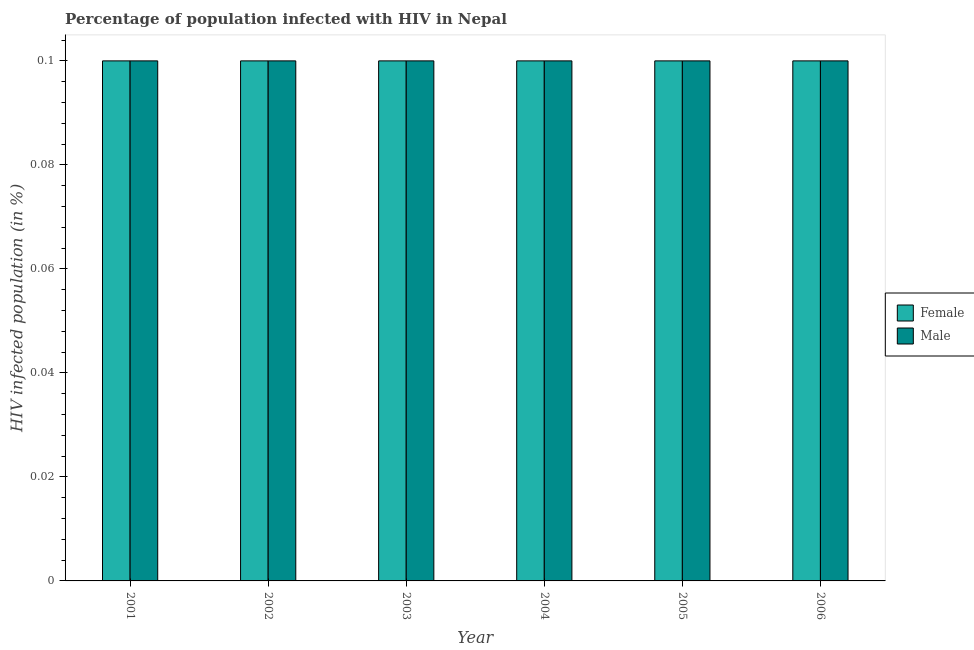How many groups of bars are there?
Your answer should be very brief. 6. Are the number of bars on each tick of the X-axis equal?
Offer a terse response. Yes. How many bars are there on the 2nd tick from the right?
Offer a very short reply. 2. What is the label of the 1st group of bars from the left?
Your response must be concise. 2001. In how many cases, is the number of bars for a given year not equal to the number of legend labels?
Ensure brevity in your answer.  0. Across all years, what is the maximum percentage of females who are infected with hiv?
Your answer should be very brief. 0.1. In which year was the percentage of males who are infected with hiv maximum?
Offer a very short reply. 2001. In which year was the percentage of females who are infected with hiv minimum?
Your answer should be very brief. 2001. What is the average percentage of males who are infected with hiv per year?
Provide a succinct answer. 0.1. In how many years, is the percentage of males who are infected with hiv greater than 0.092 %?
Your answer should be very brief. 6. What is the ratio of the percentage of females who are infected with hiv in 2002 to that in 2005?
Offer a terse response. 1. Is the percentage of males who are infected with hiv in 2002 less than that in 2006?
Your answer should be very brief. No. Is the difference between the percentage of males who are infected with hiv in 2002 and 2005 greater than the difference between the percentage of females who are infected with hiv in 2002 and 2005?
Your answer should be compact. No. What is the difference between the highest and the lowest percentage of females who are infected with hiv?
Your response must be concise. 0. Is the sum of the percentage of males who are infected with hiv in 2002 and 2004 greater than the maximum percentage of females who are infected with hiv across all years?
Your answer should be compact. Yes. What does the 1st bar from the left in 2005 represents?
Keep it short and to the point. Female. How many bars are there?
Keep it short and to the point. 12. Does the graph contain any zero values?
Offer a terse response. No. What is the title of the graph?
Your answer should be very brief. Percentage of population infected with HIV in Nepal. Does "Total Population" appear as one of the legend labels in the graph?
Offer a very short reply. No. What is the label or title of the X-axis?
Offer a terse response. Year. What is the label or title of the Y-axis?
Keep it short and to the point. HIV infected population (in %). What is the HIV infected population (in %) in Male in 2001?
Give a very brief answer. 0.1. What is the HIV infected population (in %) of Male in 2002?
Your answer should be very brief. 0.1. What is the HIV infected population (in %) in Male in 2004?
Make the answer very short. 0.1. What is the HIV infected population (in %) of Female in 2005?
Give a very brief answer. 0.1. What is the HIV infected population (in %) of Male in 2005?
Provide a succinct answer. 0.1. What is the HIV infected population (in %) of Male in 2006?
Your answer should be very brief. 0.1. Across all years, what is the maximum HIV infected population (in %) in Female?
Keep it short and to the point. 0.1. Across all years, what is the maximum HIV infected population (in %) in Male?
Your answer should be very brief. 0.1. What is the total HIV infected population (in %) of Female in the graph?
Keep it short and to the point. 0.6. What is the difference between the HIV infected population (in %) of Female in 2001 and that in 2003?
Your response must be concise. 0. What is the difference between the HIV infected population (in %) in Male in 2001 and that in 2004?
Your answer should be very brief. 0. What is the difference between the HIV infected population (in %) in Female in 2001 and that in 2005?
Offer a terse response. 0. What is the difference between the HIV infected population (in %) in Male in 2001 and that in 2005?
Offer a very short reply. 0. What is the difference between the HIV infected population (in %) in Female in 2002 and that in 2003?
Give a very brief answer. 0. What is the difference between the HIV infected population (in %) in Male in 2002 and that in 2003?
Ensure brevity in your answer.  0. What is the difference between the HIV infected population (in %) of Female in 2002 and that in 2004?
Provide a short and direct response. 0. What is the difference between the HIV infected population (in %) of Male in 2002 and that in 2004?
Ensure brevity in your answer.  0. What is the difference between the HIV infected population (in %) in Male in 2002 and that in 2006?
Provide a short and direct response. 0. What is the difference between the HIV infected population (in %) of Female in 2003 and that in 2005?
Provide a short and direct response. 0. What is the difference between the HIV infected population (in %) in Female in 2005 and that in 2006?
Keep it short and to the point. 0. What is the difference between the HIV infected population (in %) of Female in 2002 and the HIV infected population (in %) of Male in 2006?
Offer a very short reply. 0. What is the difference between the HIV infected population (in %) in Female in 2004 and the HIV infected population (in %) in Male in 2005?
Your answer should be very brief. 0. What is the difference between the HIV infected population (in %) in Female in 2005 and the HIV infected population (in %) in Male in 2006?
Your response must be concise. 0. In the year 2001, what is the difference between the HIV infected population (in %) of Female and HIV infected population (in %) of Male?
Your answer should be very brief. 0. In the year 2003, what is the difference between the HIV infected population (in %) of Female and HIV infected population (in %) of Male?
Your response must be concise. 0. In the year 2004, what is the difference between the HIV infected population (in %) of Female and HIV infected population (in %) of Male?
Provide a short and direct response. 0. In the year 2005, what is the difference between the HIV infected population (in %) in Female and HIV infected population (in %) in Male?
Your response must be concise. 0. What is the ratio of the HIV infected population (in %) in Female in 2001 to that in 2003?
Your answer should be very brief. 1. What is the ratio of the HIV infected population (in %) of Male in 2001 to that in 2004?
Give a very brief answer. 1. What is the ratio of the HIV infected population (in %) of Male in 2001 to that in 2005?
Ensure brevity in your answer.  1. What is the ratio of the HIV infected population (in %) of Male in 2001 to that in 2006?
Give a very brief answer. 1. What is the ratio of the HIV infected population (in %) of Female in 2002 to that in 2003?
Ensure brevity in your answer.  1. What is the ratio of the HIV infected population (in %) in Male in 2002 to that in 2003?
Your response must be concise. 1. What is the ratio of the HIV infected population (in %) in Female in 2002 to that in 2004?
Keep it short and to the point. 1. What is the ratio of the HIV infected population (in %) of Male in 2002 to that in 2004?
Offer a terse response. 1. What is the ratio of the HIV infected population (in %) of Female in 2003 to that in 2005?
Ensure brevity in your answer.  1. What is the ratio of the HIV infected population (in %) in Male in 2003 to that in 2005?
Your answer should be compact. 1. What is the ratio of the HIV infected population (in %) of Female in 2004 to that in 2006?
Provide a short and direct response. 1. What is the ratio of the HIV infected population (in %) in Male in 2004 to that in 2006?
Your answer should be very brief. 1. What is the ratio of the HIV infected population (in %) in Male in 2005 to that in 2006?
Give a very brief answer. 1. What is the difference between the highest and the second highest HIV infected population (in %) in Male?
Give a very brief answer. 0. What is the difference between the highest and the lowest HIV infected population (in %) of Female?
Offer a very short reply. 0. 